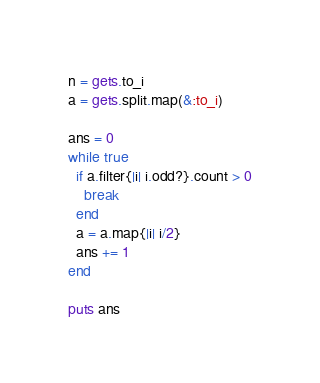Convert code to text. <code><loc_0><loc_0><loc_500><loc_500><_Ruby_>n = gets.to_i
a = gets.split.map(&:to_i)

ans = 0
while true
  if a.filter{|i| i.odd?}.count > 0
    break
  end
  a = a.map{|i| i/2}
  ans += 1
end

puts ans</code> 